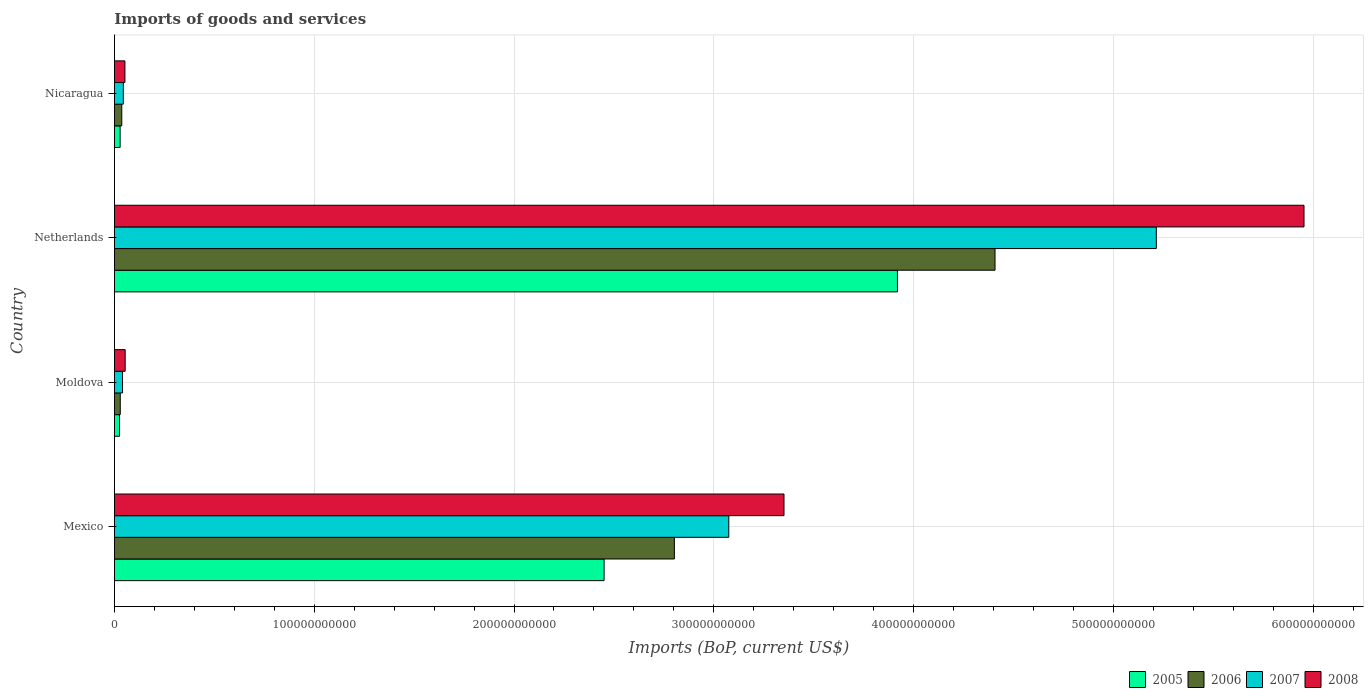How many different coloured bars are there?
Provide a succinct answer. 4. What is the label of the 1st group of bars from the top?
Provide a succinct answer. Nicaragua. What is the amount spent on imports in 2007 in Moldova?
Keep it short and to the point. 4.07e+09. Across all countries, what is the maximum amount spent on imports in 2007?
Ensure brevity in your answer.  5.22e+11. Across all countries, what is the minimum amount spent on imports in 2007?
Offer a very short reply. 4.07e+09. In which country was the amount spent on imports in 2006 maximum?
Provide a short and direct response. Netherlands. In which country was the amount spent on imports in 2007 minimum?
Your response must be concise. Moldova. What is the total amount spent on imports in 2005 in the graph?
Give a very brief answer. 6.42e+11. What is the difference between the amount spent on imports in 2008 in Mexico and that in Nicaragua?
Give a very brief answer. 3.30e+11. What is the difference between the amount spent on imports in 2006 in Moldova and the amount spent on imports in 2005 in Mexico?
Provide a short and direct response. -2.42e+11. What is the average amount spent on imports in 2006 per country?
Give a very brief answer. 1.82e+11. What is the difference between the amount spent on imports in 2008 and amount spent on imports in 2005 in Netherlands?
Offer a very short reply. 2.04e+11. In how many countries, is the amount spent on imports in 2005 greater than 460000000000 US$?
Ensure brevity in your answer.  0. What is the ratio of the amount spent on imports in 2007 in Mexico to that in Netherlands?
Your answer should be very brief. 0.59. Is the difference between the amount spent on imports in 2008 in Moldova and Netherlands greater than the difference between the amount spent on imports in 2005 in Moldova and Netherlands?
Give a very brief answer. No. What is the difference between the highest and the second highest amount spent on imports in 2007?
Give a very brief answer. 2.14e+11. What is the difference between the highest and the lowest amount spent on imports in 2006?
Your answer should be very brief. 4.38e+11. In how many countries, is the amount spent on imports in 2005 greater than the average amount spent on imports in 2005 taken over all countries?
Your answer should be compact. 2. What does the 2nd bar from the bottom in Mexico represents?
Ensure brevity in your answer.  2006. Is it the case that in every country, the sum of the amount spent on imports in 2006 and amount spent on imports in 2005 is greater than the amount spent on imports in 2007?
Offer a very short reply. Yes. Are all the bars in the graph horizontal?
Keep it short and to the point. Yes. How many countries are there in the graph?
Make the answer very short. 4. What is the difference between two consecutive major ticks on the X-axis?
Make the answer very short. 1.00e+11. Where does the legend appear in the graph?
Your response must be concise. Bottom right. How are the legend labels stacked?
Provide a succinct answer. Horizontal. What is the title of the graph?
Provide a succinct answer. Imports of goods and services. What is the label or title of the X-axis?
Give a very brief answer. Imports (BoP, current US$). What is the label or title of the Y-axis?
Keep it short and to the point. Country. What is the Imports (BoP, current US$) of 2005 in Mexico?
Your answer should be compact. 2.45e+11. What is the Imports (BoP, current US$) of 2006 in Mexico?
Keep it short and to the point. 2.80e+11. What is the Imports (BoP, current US$) of 2007 in Mexico?
Offer a very short reply. 3.08e+11. What is the Imports (BoP, current US$) in 2008 in Mexico?
Give a very brief answer. 3.35e+11. What is the Imports (BoP, current US$) in 2005 in Moldova?
Provide a short and direct response. 2.54e+09. What is the Imports (BoP, current US$) in 2006 in Moldova?
Give a very brief answer. 2.93e+09. What is the Imports (BoP, current US$) in 2007 in Moldova?
Offer a very short reply. 4.07e+09. What is the Imports (BoP, current US$) of 2008 in Moldova?
Your response must be concise. 5.37e+09. What is the Imports (BoP, current US$) in 2005 in Netherlands?
Offer a very short reply. 3.92e+11. What is the Imports (BoP, current US$) in 2006 in Netherlands?
Ensure brevity in your answer.  4.41e+11. What is the Imports (BoP, current US$) in 2007 in Netherlands?
Keep it short and to the point. 5.22e+11. What is the Imports (BoP, current US$) in 2008 in Netherlands?
Keep it short and to the point. 5.95e+11. What is the Imports (BoP, current US$) in 2005 in Nicaragua?
Your response must be concise. 2.85e+09. What is the Imports (BoP, current US$) of 2006 in Nicaragua?
Provide a succinct answer. 3.68e+09. What is the Imports (BoP, current US$) of 2007 in Nicaragua?
Ensure brevity in your answer.  4.45e+09. What is the Imports (BoP, current US$) of 2008 in Nicaragua?
Provide a short and direct response. 5.26e+09. Across all countries, what is the maximum Imports (BoP, current US$) of 2005?
Your response must be concise. 3.92e+11. Across all countries, what is the maximum Imports (BoP, current US$) in 2006?
Offer a terse response. 4.41e+11. Across all countries, what is the maximum Imports (BoP, current US$) in 2007?
Provide a succinct answer. 5.22e+11. Across all countries, what is the maximum Imports (BoP, current US$) of 2008?
Offer a terse response. 5.95e+11. Across all countries, what is the minimum Imports (BoP, current US$) of 2005?
Keep it short and to the point. 2.54e+09. Across all countries, what is the minimum Imports (BoP, current US$) in 2006?
Make the answer very short. 2.93e+09. Across all countries, what is the minimum Imports (BoP, current US$) in 2007?
Keep it short and to the point. 4.07e+09. Across all countries, what is the minimum Imports (BoP, current US$) in 2008?
Your answer should be compact. 5.26e+09. What is the total Imports (BoP, current US$) in 2005 in the graph?
Your answer should be very brief. 6.42e+11. What is the total Imports (BoP, current US$) of 2006 in the graph?
Keep it short and to the point. 7.28e+11. What is the total Imports (BoP, current US$) of 2007 in the graph?
Provide a short and direct response. 8.38e+11. What is the total Imports (BoP, current US$) of 2008 in the graph?
Make the answer very short. 9.41e+11. What is the difference between the Imports (BoP, current US$) of 2005 in Mexico and that in Moldova?
Your answer should be very brief. 2.43e+11. What is the difference between the Imports (BoP, current US$) of 2006 in Mexico and that in Moldova?
Provide a succinct answer. 2.77e+11. What is the difference between the Imports (BoP, current US$) of 2007 in Mexico and that in Moldova?
Ensure brevity in your answer.  3.03e+11. What is the difference between the Imports (BoP, current US$) of 2008 in Mexico and that in Moldova?
Make the answer very short. 3.30e+11. What is the difference between the Imports (BoP, current US$) in 2005 in Mexico and that in Netherlands?
Make the answer very short. -1.47e+11. What is the difference between the Imports (BoP, current US$) of 2006 in Mexico and that in Netherlands?
Ensure brevity in your answer.  -1.61e+11. What is the difference between the Imports (BoP, current US$) in 2007 in Mexico and that in Netherlands?
Your answer should be very brief. -2.14e+11. What is the difference between the Imports (BoP, current US$) in 2008 in Mexico and that in Netherlands?
Provide a short and direct response. -2.60e+11. What is the difference between the Imports (BoP, current US$) of 2005 in Mexico and that in Nicaragua?
Keep it short and to the point. 2.42e+11. What is the difference between the Imports (BoP, current US$) of 2006 in Mexico and that in Nicaragua?
Your answer should be very brief. 2.77e+11. What is the difference between the Imports (BoP, current US$) in 2007 in Mexico and that in Nicaragua?
Ensure brevity in your answer.  3.03e+11. What is the difference between the Imports (BoP, current US$) in 2008 in Mexico and that in Nicaragua?
Make the answer very short. 3.30e+11. What is the difference between the Imports (BoP, current US$) in 2005 in Moldova and that in Netherlands?
Make the answer very short. -3.89e+11. What is the difference between the Imports (BoP, current US$) in 2006 in Moldova and that in Netherlands?
Provide a short and direct response. -4.38e+11. What is the difference between the Imports (BoP, current US$) in 2007 in Moldova and that in Netherlands?
Ensure brevity in your answer.  -5.17e+11. What is the difference between the Imports (BoP, current US$) in 2008 in Moldova and that in Netherlands?
Provide a short and direct response. -5.90e+11. What is the difference between the Imports (BoP, current US$) of 2005 in Moldova and that in Nicaragua?
Provide a short and direct response. -3.08e+08. What is the difference between the Imports (BoP, current US$) of 2006 in Moldova and that in Nicaragua?
Your response must be concise. -7.55e+08. What is the difference between the Imports (BoP, current US$) in 2007 in Moldova and that in Nicaragua?
Ensure brevity in your answer.  -3.85e+08. What is the difference between the Imports (BoP, current US$) in 2008 in Moldova and that in Nicaragua?
Your response must be concise. 1.14e+08. What is the difference between the Imports (BoP, current US$) in 2005 in Netherlands and that in Nicaragua?
Your answer should be compact. 3.89e+11. What is the difference between the Imports (BoP, current US$) in 2006 in Netherlands and that in Nicaragua?
Ensure brevity in your answer.  4.37e+11. What is the difference between the Imports (BoP, current US$) of 2007 in Netherlands and that in Nicaragua?
Make the answer very short. 5.17e+11. What is the difference between the Imports (BoP, current US$) of 2008 in Netherlands and that in Nicaragua?
Provide a succinct answer. 5.90e+11. What is the difference between the Imports (BoP, current US$) of 2005 in Mexico and the Imports (BoP, current US$) of 2006 in Moldova?
Keep it short and to the point. 2.42e+11. What is the difference between the Imports (BoP, current US$) of 2005 in Mexico and the Imports (BoP, current US$) of 2007 in Moldova?
Give a very brief answer. 2.41e+11. What is the difference between the Imports (BoP, current US$) of 2005 in Mexico and the Imports (BoP, current US$) of 2008 in Moldova?
Offer a terse response. 2.40e+11. What is the difference between the Imports (BoP, current US$) of 2006 in Mexico and the Imports (BoP, current US$) of 2007 in Moldova?
Offer a terse response. 2.76e+11. What is the difference between the Imports (BoP, current US$) in 2006 in Mexico and the Imports (BoP, current US$) in 2008 in Moldova?
Offer a terse response. 2.75e+11. What is the difference between the Imports (BoP, current US$) in 2007 in Mexico and the Imports (BoP, current US$) in 2008 in Moldova?
Provide a short and direct response. 3.02e+11. What is the difference between the Imports (BoP, current US$) of 2005 in Mexico and the Imports (BoP, current US$) of 2006 in Netherlands?
Provide a short and direct response. -1.96e+11. What is the difference between the Imports (BoP, current US$) in 2005 in Mexico and the Imports (BoP, current US$) in 2007 in Netherlands?
Offer a very short reply. -2.76e+11. What is the difference between the Imports (BoP, current US$) in 2005 in Mexico and the Imports (BoP, current US$) in 2008 in Netherlands?
Your answer should be compact. -3.50e+11. What is the difference between the Imports (BoP, current US$) of 2006 in Mexico and the Imports (BoP, current US$) of 2007 in Netherlands?
Offer a terse response. -2.41e+11. What is the difference between the Imports (BoP, current US$) of 2006 in Mexico and the Imports (BoP, current US$) of 2008 in Netherlands?
Offer a very short reply. -3.15e+11. What is the difference between the Imports (BoP, current US$) of 2007 in Mexico and the Imports (BoP, current US$) of 2008 in Netherlands?
Your response must be concise. -2.88e+11. What is the difference between the Imports (BoP, current US$) in 2005 in Mexico and the Imports (BoP, current US$) in 2006 in Nicaragua?
Offer a terse response. 2.41e+11. What is the difference between the Imports (BoP, current US$) of 2005 in Mexico and the Imports (BoP, current US$) of 2007 in Nicaragua?
Ensure brevity in your answer.  2.41e+11. What is the difference between the Imports (BoP, current US$) of 2005 in Mexico and the Imports (BoP, current US$) of 2008 in Nicaragua?
Give a very brief answer. 2.40e+11. What is the difference between the Imports (BoP, current US$) of 2006 in Mexico and the Imports (BoP, current US$) of 2007 in Nicaragua?
Provide a succinct answer. 2.76e+11. What is the difference between the Imports (BoP, current US$) in 2006 in Mexico and the Imports (BoP, current US$) in 2008 in Nicaragua?
Your answer should be compact. 2.75e+11. What is the difference between the Imports (BoP, current US$) in 2007 in Mexico and the Imports (BoP, current US$) in 2008 in Nicaragua?
Keep it short and to the point. 3.02e+11. What is the difference between the Imports (BoP, current US$) of 2005 in Moldova and the Imports (BoP, current US$) of 2006 in Netherlands?
Offer a very short reply. -4.38e+11. What is the difference between the Imports (BoP, current US$) in 2005 in Moldova and the Imports (BoP, current US$) in 2007 in Netherlands?
Your response must be concise. -5.19e+11. What is the difference between the Imports (BoP, current US$) of 2005 in Moldova and the Imports (BoP, current US$) of 2008 in Netherlands?
Provide a short and direct response. -5.93e+11. What is the difference between the Imports (BoP, current US$) of 2006 in Moldova and the Imports (BoP, current US$) of 2007 in Netherlands?
Make the answer very short. -5.19e+11. What is the difference between the Imports (BoP, current US$) of 2006 in Moldova and the Imports (BoP, current US$) of 2008 in Netherlands?
Offer a terse response. -5.93e+11. What is the difference between the Imports (BoP, current US$) in 2007 in Moldova and the Imports (BoP, current US$) in 2008 in Netherlands?
Provide a succinct answer. -5.91e+11. What is the difference between the Imports (BoP, current US$) in 2005 in Moldova and the Imports (BoP, current US$) in 2006 in Nicaragua?
Give a very brief answer. -1.14e+09. What is the difference between the Imports (BoP, current US$) in 2005 in Moldova and the Imports (BoP, current US$) in 2007 in Nicaragua?
Your answer should be very brief. -1.91e+09. What is the difference between the Imports (BoP, current US$) of 2005 in Moldova and the Imports (BoP, current US$) of 2008 in Nicaragua?
Provide a short and direct response. -2.71e+09. What is the difference between the Imports (BoP, current US$) of 2006 in Moldova and the Imports (BoP, current US$) of 2007 in Nicaragua?
Give a very brief answer. -1.53e+09. What is the difference between the Imports (BoP, current US$) in 2006 in Moldova and the Imports (BoP, current US$) in 2008 in Nicaragua?
Provide a succinct answer. -2.33e+09. What is the difference between the Imports (BoP, current US$) of 2007 in Moldova and the Imports (BoP, current US$) of 2008 in Nicaragua?
Offer a terse response. -1.19e+09. What is the difference between the Imports (BoP, current US$) of 2005 in Netherlands and the Imports (BoP, current US$) of 2006 in Nicaragua?
Offer a very short reply. 3.88e+11. What is the difference between the Imports (BoP, current US$) in 2005 in Netherlands and the Imports (BoP, current US$) in 2007 in Nicaragua?
Make the answer very short. 3.87e+11. What is the difference between the Imports (BoP, current US$) of 2005 in Netherlands and the Imports (BoP, current US$) of 2008 in Nicaragua?
Your response must be concise. 3.87e+11. What is the difference between the Imports (BoP, current US$) of 2006 in Netherlands and the Imports (BoP, current US$) of 2007 in Nicaragua?
Offer a very short reply. 4.36e+11. What is the difference between the Imports (BoP, current US$) in 2006 in Netherlands and the Imports (BoP, current US$) in 2008 in Nicaragua?
Your response must be concise. 4.36e+11. What is the difference between the Imports (BoP, current US$) in 2007 in Netherlands and the Imports (BoP, current US$) in 2008 in Nicaragua?
Give a very brief answer. 5.16e+11. What is the average Imports (BoP, current US$) in 2005 per country?
Provide a short and direct response. 1.61e+11. What is the average Imports (BoP, current US$) in 2006 per country?
Ensure brevity in your answer.  1.82e+11. What is the average Imports (BoP, current US$) in 2007 per country?
Ensure brevity in your answer.  2.09e+11. What is the average Imports (BoP, current US$) in 2008 per country?
Your answer should be compact. 2.35e+11. What is the difference between the Imports (BoP, current US$) in 2005 and Imports (BoP, current US$) in 2006 in Mexico?
Provide a short and direct response. -3.52e+1. What is the difference between the Imports (BoP, current US$) in 2005 and Imports (BoP, current US$) in 2007 in Mexico?
Ensure brevity in your answer.  -6.24e+1. What is the difference between the Imports (BoP, current US$) of 2005 and Imports (BoP, current US$) of 2008 in Mexico?
Provide a short and direct response. -9.00e+1. What is the difference between the Imports (BoP, current US$) of 2006 and Imports (BoP, current US$) of 2007 in Mexico?
Your answer should be very brief. -2.72e+1. What is the difference between the Imports (BoP, current US$) in 2006 and Imports (BoP, current US$) in 2008 in Mexico?
Provide a succinct answer. -5.49e+1. What is the difference between the Imports (BoP, current US$) in 2007 and Imports (BoP, current US$) in 2008 in Mexico?
Your response must be concise. -2.76e+1. What is the difference between the Imports (BoP, current US$) in 2005 and Imports (BoP, current US$) in 2006 in Moldova?
Make the answer very short. -3.81e+08. What is the difference between the Imports (BoP, current US$) of 2005 and Imports (BoP, current US$) of 2007 in Moldova?
Provide a short and direct response. -1.52e+09. What is the difference between the Imports (BoP, current US$) of 2005 and Imports (BoP, current US$) of 2008 in Moldova?
Your answer should be very brief. -2.82e+09. What is the difference between the Imports (BoP, current US$) in 2006 and Imports (BoP, current US$) in 2007 in Moldova?
Make the answer very short. -1.14e+09. What is the difference between the Imports (BoP, current US$) in 2006 and Imports (BoP, current US$) in 2008 in Moldova?
Give a very brief answer. -2.44e+09. What is the difference between the Imports (BoP, current US$) in 2007 and Imports (BoP, current US$) in 2008 in Moldova?
Your response must be concise. -1.30e+09. What is the difference between the Imports (BoP, current US$) of 2005 and Imports (BoP, current US$) of 2006 in Netherlands?
Give a very brief answer. -4.88e+1. What is the difference between the Imports (BoP, current US$) in 2005 and Imports (BoP, current US$) in 2007 in Netherlands?
Keep it short and to the point. -1.30e+11. What is the difference between the Imports (BoP, current US$) of 2005 and Imports (BoP, current US$) of 2008 in Netherlands?
Your answer should be very brief. -2.04e+11. What is the difference between the Imports (BoP, current US$) of 2006 and Imports (BoP, current US$) of 2007 in Netherlands?
Give a very brief answer. -8.07e+1. What is the difference between the Imports (BoP, current US$) in 2006 and Imports (BoP, current US$) in 2008 in Netherlands?
Your response must be concise. -1.55e+11. What is the difference between the Imports (BoP, current US$) of 2007 and Imports (BoP, current US$) of 2008 in Netherlands?
Your answer should be compact. -7.39e+1. What is the difference between the Imports (BoP, current US$) in 2005 and Imports (BoP, current US$) in 2006 in Nicaragua?
Make the answer very short. -8.28e+08. What is the difference between the Imports (BoP, current US$) in 2005 and Imports (BoP, current US$) in 2007 in Nicaragua?
Provide a succinct answer. -1.60e+09. What is the difference between the Imports (BoP, current US$) of 2005 and Imports (BoP, current US$) of 2008 in Nicaragua?
Give a very brief answer. -2.40e+09. What is the difference between the Imports (BoP, current US$) of 2006 and Imports (BoP, current US$) of 2007 in Nicaragua?
Your response must be concise. -7.70e+08. What is the difference between the Imports (BoP, current US$) of 2006 and Imports (BoP, current US$) of 2008 in Nicaragua?
Your answer should be compact. -1.57e+09. What is the difference between the Imports (BoP, current US$) of 2007 and Imports (BoP, current US$) of 2008 in Nicaragua?
Offer a terse response. -8.05e+08. What is the ratio of the Imports (BoP, current US$) in 2005 in Mexico to that in Moldova?
Provide a succinct answer. 96.33. What is the ratio of the Imports (BoP, current US$) of 2006 in Mexico to that in Moldova?
Offer a terse response. 95.81. What is the ratio of the Imports (BoP, current US$) in 2007 in Mexico to that in Moldova?
Keep it short and to the point. 75.64. What is the ratio of the Imports (BoP, current US$) in 2008 in Mexico to that in Moldova?
Your response must be concise. 62.42. What is the ratio of the Imports (BoP, current US$) in 2005 in Mexico to that in Netherlands?
Your response must be concise. 0.63. What is the ratio of the Imports (BoP, current US$) of 2006 in Mexico to that in Netherlands?
Make the answer very short. 0.64. What is the ratio of the Imports (BoP, current US$) of 2007 in Mexico to that in Netherlands?
Provide a succinct answer. 0.59. What is the ratio of the Imports (BoP, current US$) in 2008 in Mexico to that in Netherlands?
Give a very brief answer. 0.56. What is the ratio of the Imports (BoP, current US$) of 2005 in Mexico to that in Nicaragua?
Give a very brief answer. 85.92. What is the ratio of the Imports (BoP, current US$) of 2006 in Mexico to that in Nicaragua?
Offer a very short reply. 76.15. What is the ratio of the Imports (BoP, current US$) of 2007 in Mexico to that in Nicaragua?
Your answer should be very brief. 69.09. What is the ratio of the Imports (BoP, current US$) in 2008 in Mexico to that in Nicaragua?
Offer a very short reply. 63.77. What is the ratio of the Imports (BoP, current US$) in 2005 in Moldova to that in Netherlands?
Ensure brevity in your answer.  0.01. What is the ratio of the Imports (BoP, current US$) in 2006 in Moldova to that in Netherlands?
Your response must be concise. 0.01. What is the ratio of the Imports (BoP, current US$) in 2007 in Moldova to that in Netherlands?
Your answer should be compact. 0.01. What is the ratio of the Imports (BoP, current US$) of 2008 in Moldova to that in Netherlands?
Offer a very short reply. 0.01. What is the ratio of the Imports (BoP, current US$) of 2005 in Moldova to that in Nicaragua?
Offer a terse response. 0.89. What is the ratio of the Imports (BoP, current US$) in 2006 in Moldova to that in Nicaragua?
Provide a short and direct response. 0.79. What is the ratio of the Imports (BoP, current US$) of 2007 in Moldova to that in Nicaragua?
Provide a short and direct response. 0.91. What is the ratio of the Imports (BoP, current US$) in 2008 in Moldova to that in Nicaragua?
Your response must be concise. 1.02. What is the ratio of the Imports (BoP, current US$) in 2005 in Netherlands to that in Nicaragua?
Offer a terse response. 137.38. What is the ratio of the Imports (BoP, current US$) in 2006 in Netherlands to that in Nicaragua?
Your answer should be very brief. 119.75. What is the ratio of the Imports (BoP, current US$) in 2007 in Netherlands to that in Nicaragua?
Give a very brief answer. 117.17. What is the ratio of the Imports (BoP, current US$) in 2008 in Netherlands to that in Nicaragua?
Give a very brief answer. 113.3. What is the difference between the highest and the second highest Imports (BoP, current US$) of 2005?
Provide a short and direct response. 1.47e+11. What is the difference between the highest and the second highest Imports (BoP, current US$) of 2006?
Provide a short and direct response. 1.61e+11. What is the difference between the highest and the second highest Imports (BoP, current US$) in 2007?
Offer a very short reply. 2.14e+11. What is the difference between the highest and the second highest Imports (BoP, current US$) in 2008?
Keep it short and to the point. 2.60e+11. What is the difference between the highest and the lowest Imports (BoP, current US$) in 2005?
Your answer should be very brief. 3.89e+11. What is the difference between the highest and the lowest Imports (BoP, current US$) of 2006?
Offer a very short reply. 4.38e+11. What is the difference between the highest and the lowest Imports (BoP, current US$) of 2007?
Provide a short and direct response. 5.17e+11. What is the difference between the highest and the lowest Imports (BoP, current US$) in 2008?
Ensure brevity in your answer.  5.90e+11. 